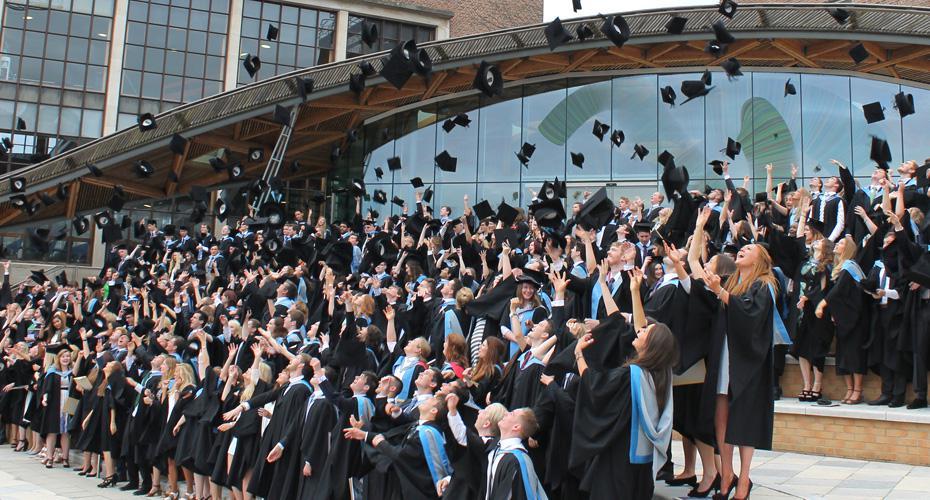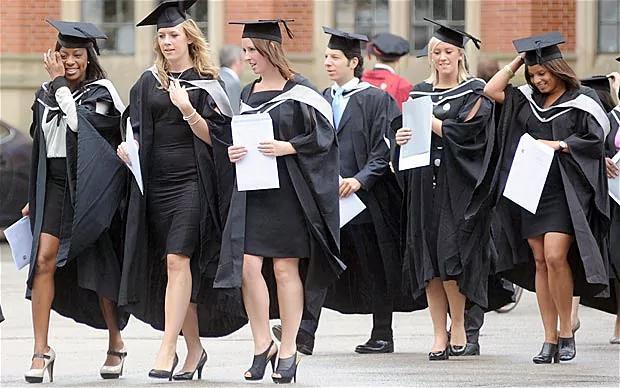The first image is the image on the left, the second image is the image on the right. Assess this claim about the two images: "Two graduates stand together outside posing for a picture in the image on the left.". Correct or not? Answer yes or no. No. The first image is the image on the left, the second image is the image on the right. Analyze the images presented: Is the assertion "The right image shows multiple black-robed graduates wearing caps and  bright sky-blue sashes." valid? Answer yes or no. No. 